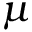<formula> <loc_0><loc_0><loc_500><loc_500>\mu</formula> 